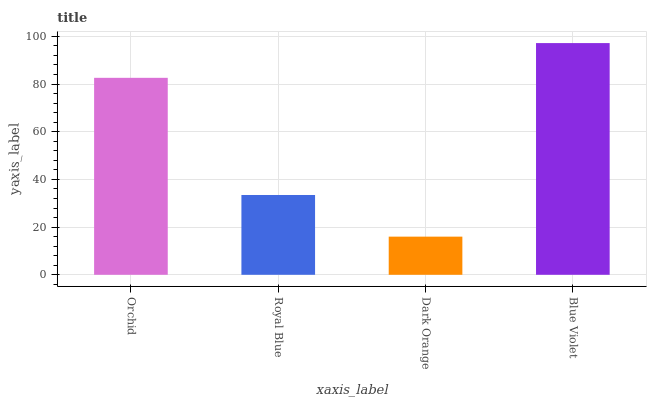Is Dark Orange the minimum?
Answer yes or no. Yes. Is Blue Violet the maximum?
Answer yes or no. Yes. Is Royal Blue the minimum?
Answer yes or no. No. Is Royal Blue the maximum?
Answer yes or no. No. Is Orchid greater than Royal Blue?
Answer yes or no. Yes. Is Royal Blue less than Orchid?
Answer yes or no. Yes. Is Royal Blue greater than Orchid?
Answer yes or no. No. Is Orchid less than Royal Blue?
Answer yes or no. No. Is Orchid the high median?
Answer yes or no. Yes. Is Royal Blue the low median?
Answer yes or no. Yes. Is Royal Blue the high median?
Answer yes or no. No. Is Orchid the low median?
Answer yes or no. No. 